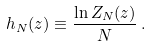<formula> <loc_0><loc_0><loc_500><loc_500>h _ { N } ( z ) \equiv \frac { \ln Z _ { N } ( z ) } { N } \, .</formula> 